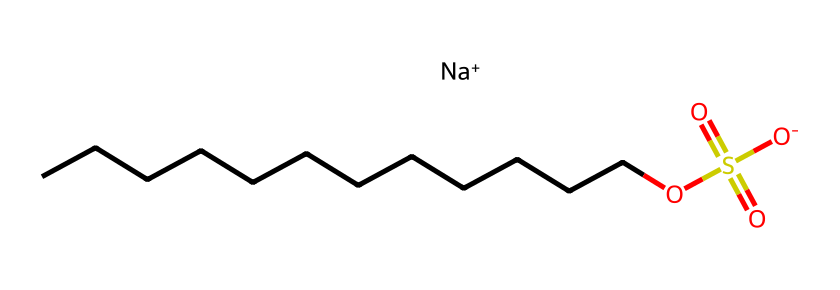How many carbon atoms are in sodium lauryl sulfate? By analyzing the SMILES representation, we can count the number of 'C' characters which represent carbon atoms. The linear chain 'CCCCCCCCCCCC' indicates there are 12 carbon atoms in total.
Answer: 12 What is the functional group present in sodium lauryl sulfate? The presence of 'OS(=O)(=O)[O-]' in the SMILES indicates that it has a sulfate group. The 'S' represents sulfur, and the 'O' atoms bonded to it exhibit the sulfate functional group characteristic.
Answer: sulfate What is the overall charge of sodium lauryl sulfate? In the SMILES notation, we see '[Na+]' which indicates that sodium has a positive charge. Additionally, the sulfate group having 'O-' indicates a negative charge. The overall structure balances to be neutral due to one positive and one negative charge.
Answer: neutral What type of bond connects the carbon atoms in the chain? The chain 'CCCCCCCCCCCC' consists exclusively of single 'C' atoms connected linearly, indicating single covalent bonds between each pair of carbon atoms.
Answer: single covalent What makes sodium lauryl sulfate an effective surfactant? Sodium lauryl sulfate has a long hydrophobic carbon chain (the 'CCCCCCCCCCCC' part) and a hydrophilic sulfate group ('OS(=O)(=O)[O-]'). This amphiphilic nature enables it to lower surface tension between liquids, making it an effective surfactant.
Answer: amphiphilic nature What is the role of the sodium ion in sodium lauryl sulfate? The sodium ion, represented as '[Na+]', acts as a counterion that balances the negative charge from the sulfate group, enhancing solubility in water and contributing to the surfactant's cleansing properties.
Answer: counterion How many oxygen atoms are present in sodium lauryl sulfate? In the sulfate group 'OS(=O)(=O)[O-]', we find four oxygen atoms linked to sulfur, as well as the oxygen in the sulfonate structure. Therefore, we count a total of four oxygen atoms from the sulfate part.
Answer: 4 